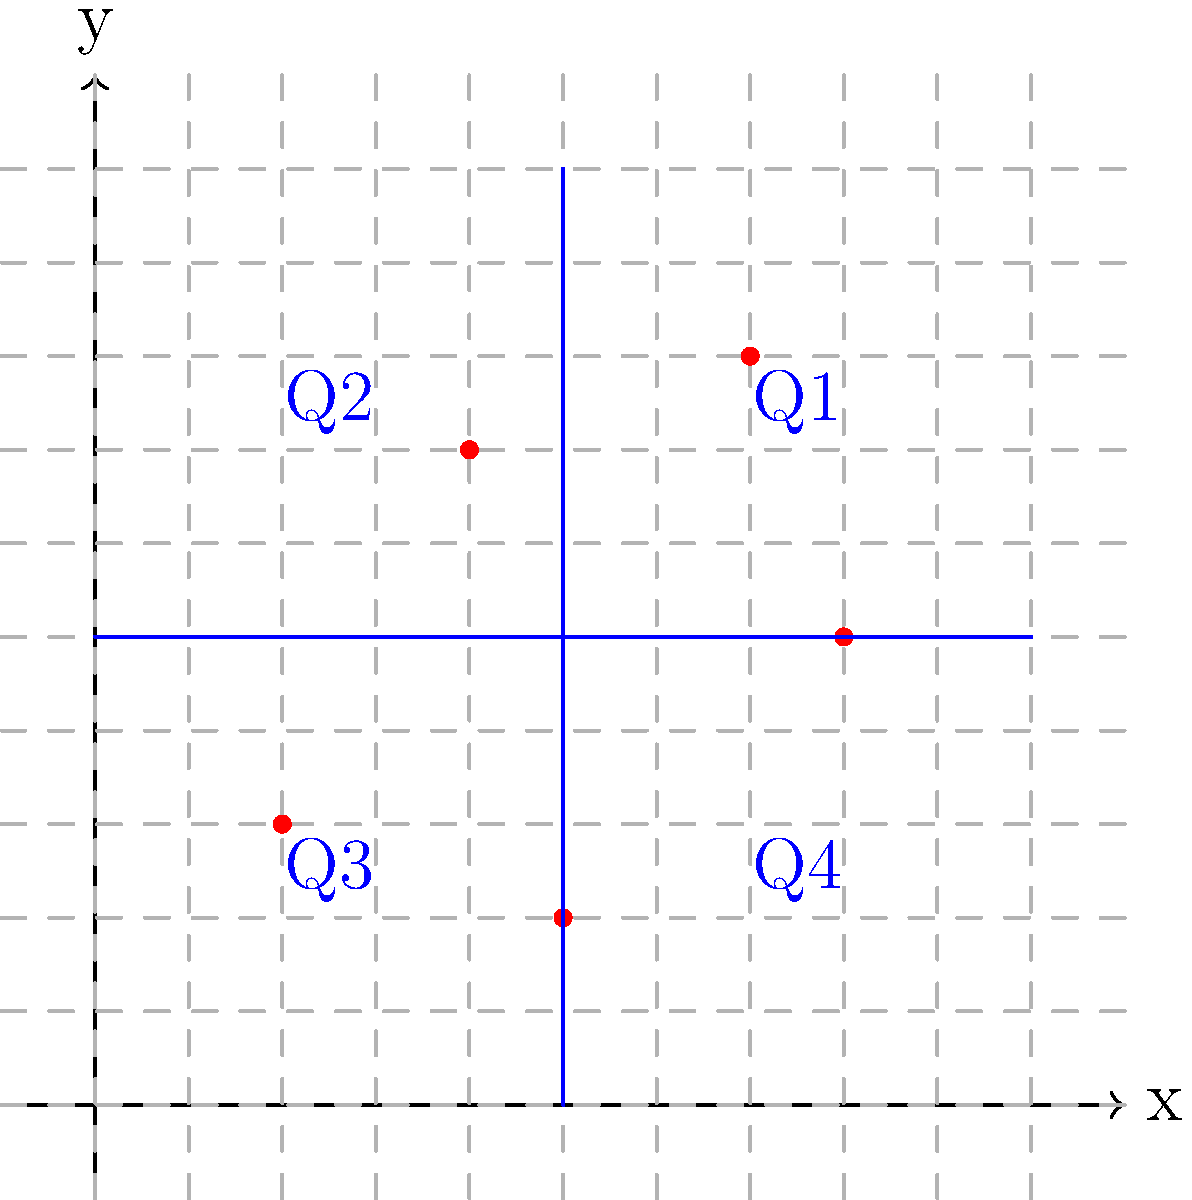A forest area has been divided into four quadrants using a coordinate system, as shown in the diagram. Each point represents a tree, and the grid spacing represents 100 meters. Calculate the tree density (trees per hectare) in Quadrant 1 (Q1). Round your answer to the nearest whole number. To calculate the tree density in Quadrant 1, we need to follow these steps:

1. Count the number of trees in Q1:
   There are 2 trees in Q1.

2. Calculate the area of Q1:
   - Each grid square is 100m x 100m = 10,000 m²
   - Q1 is 5 x 5 grid squares = 25 grid squares
   - Area of Q1 = 25 x 10,000 m² = 250,000 m² = 25 hectares
   
3. Calculate the tree density:
   Density = Number of trees / Area
   Density = 2 trees / 25 hectares = 0.08 trees/hectare

4. Convert to trees per hectare and round to the nearest whole number:
   0.08 trees/hectare x 100 = 8 trees/hectare

Therefore, the tree density in Quadrant 1 is approximately 8 trees per hectare.
Answer: 8 trees/hectare 